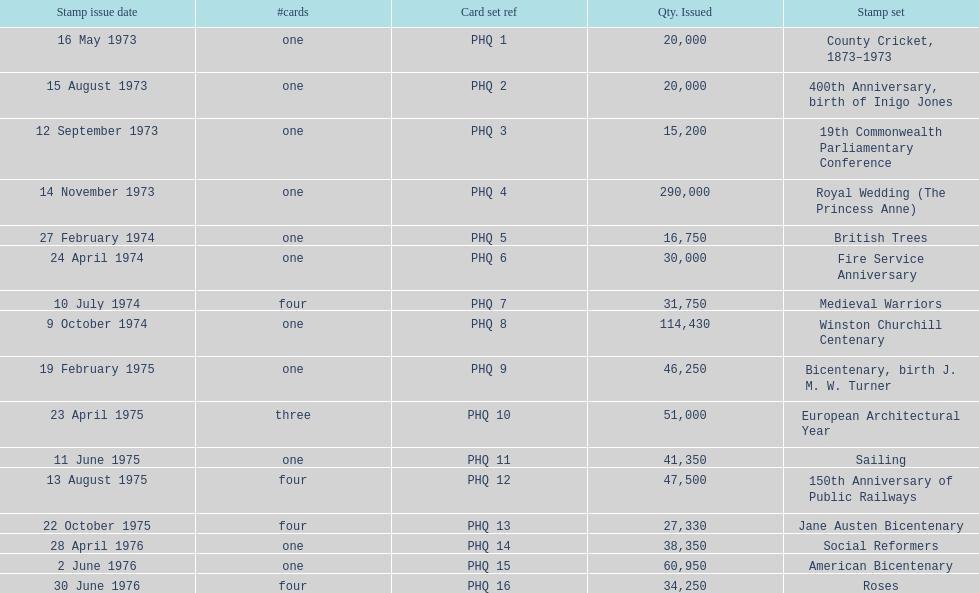How many stamp sets had at least 50,000 issued? 4. Would you be able to parse every entry in this table? {'header': ['Stamp issue date', '#cards', 'Card set ref', 'Qty. Issued', 'Stamp set'], 'rows': [['16 May 1973', 'one', 'PHQ 1', '20,000', 'County Cricket, 1873–1973'], ['15 August 1973', 'one', 'PHQ 2', '20,000', '400th Anniversary, birth of Inigo Jones'], ['12 September 1973', 'one', 'PHQ 3', '15,200', '19th Commonwealth Parliamentary Conference'], ['14 November 1973', 'one', 'PHQ 4', '290,000', 'Royal Wedding (The Princess Anne)'], ['27 February 1974', 'one', 'PHQ 5', '16,750', 'British Trees'], ['24 April 1974', 'one', 'PHQ 6', '30,000', 'Fire Service Anniversary'], ['10 July 1974', 'four', 'PHQ 7', '31,750', 'Medieval Warriors'], ['9 October 1974', 'one', 'PHQ 8', '114,430', 'Winston Churchill Centenary'], ['19 February 1975', 'one', 'PHQ 9', '46,250', 'Bicentenary, birth J. M. W. Turner'], ['23 April 1975', 'three', 'PHQ 10', '51,000', 'European Architectural Year'], ['11 June 1975', 'one', 'PHQ 11', '41,350', 'Sailing'], ['13 August 1975', 'four', 'PHQ 12', '47,500', '150th Anniversary of Public Railways'], ['22 October 1975', 'four', 'PHQ 13', '27,330', 'Jane Austen Bicentenary'], ['28 April 1976', 'one', 'PHQ 14', '38,350', 'Social Reformers'], ['2 June 1976', 'one', 'PHQ 15', '60,950', 'American Bicentenary'], ['30 June 1976', 'four', 'PHQ 16', '34,250', 'Roses']]} 